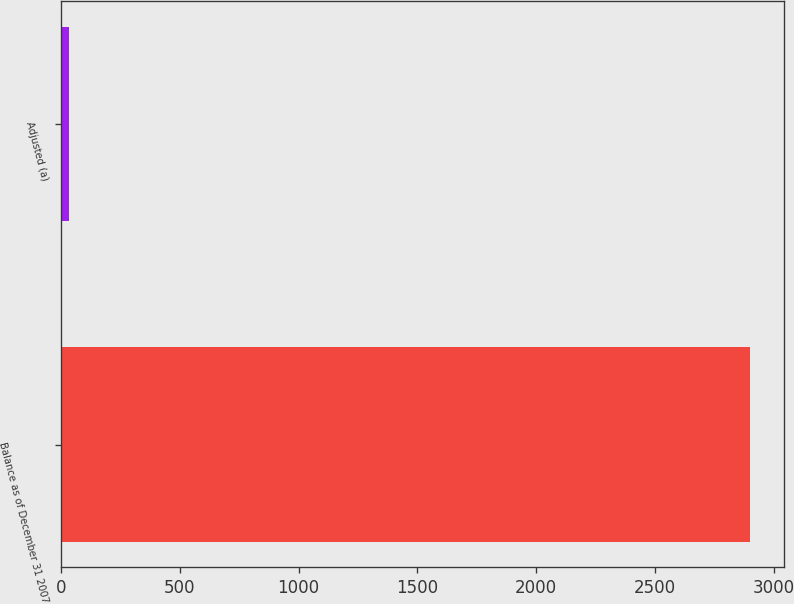<chart> <loc_0><loc_0><loc_500><loc_500><bar_chart><fcel>Balance as of December 31 2007<fcel>Adjusted (a)<nl><fcel>2899<fcel>35<nl></chart> 